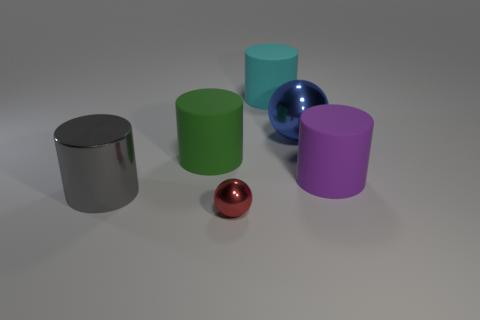Is there any other thing that has the same color as the small shiny thing?
Your response must be concise. No. What is the color of the rubber object that is left of the ball that is in front of the big gray thing?
Offer a very short reply. Green. What number of tiny things are either red spheres or red matte things?
Offer a very short reply. 1. What material is the big gray object that is the same shape as the big green thing?
Ensure brevity in your answer.  Metal. What color is the small shiny sphere?
Ensure brevity in your answer.  Red. What number of large matte cylinders are to the right of the cylinder in front of the large purple matte object?
Your response must be concise. 3. There is a object that is both in front of the blue metal thing and to the right of the large cyan thing; what is its size?
Offer a very short reply. Large. What material is the sphere that is behind the big gray shiny cylinder?
Your answer should be very brief. Metal. Is there another object that has the same shape as the blue metallic thing?
Provide a succinct answer. Yes. How many other green matte objects are the same shape as the small object?
Offer a terse response. 0. 